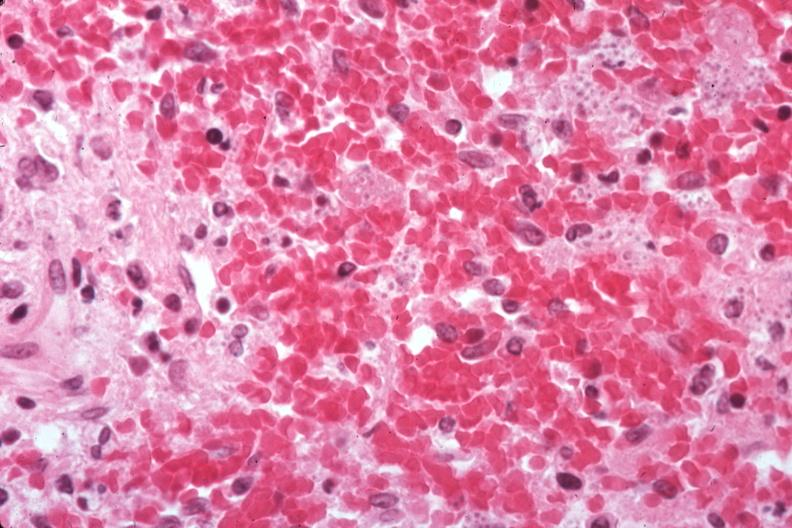s histoplasmosis present?
Answer the question using a single word or phrase. Yes 